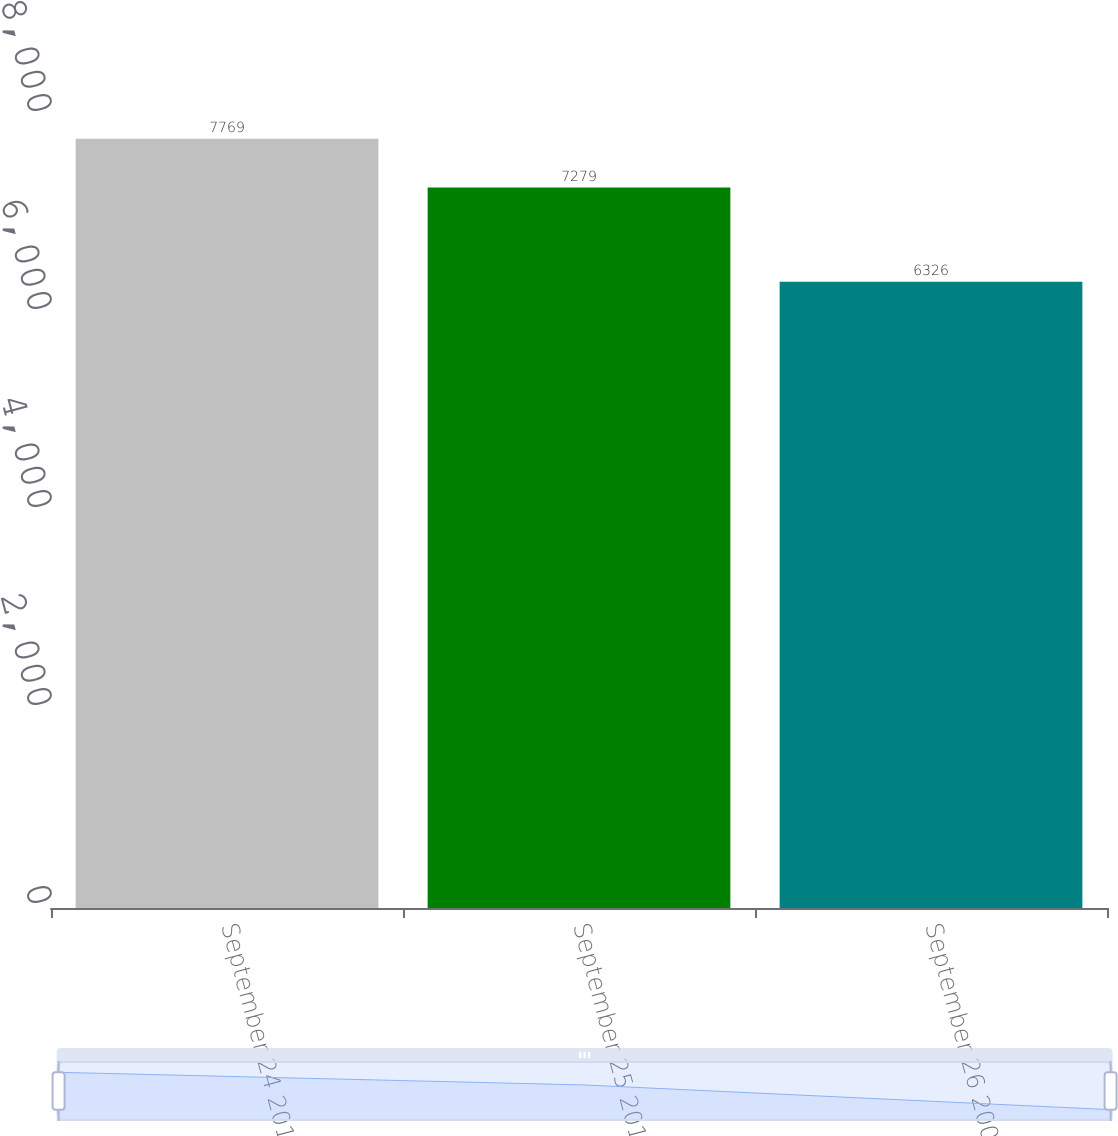<chart> <loc_0><loc_0><loc_500><loc_500><bar_chart><fcel>September 24 2011<fcel>September 25 2010<fcel>September 26 2009<nl><fcel>7769<fcel>7279<fcel>6326<nl></chart> 